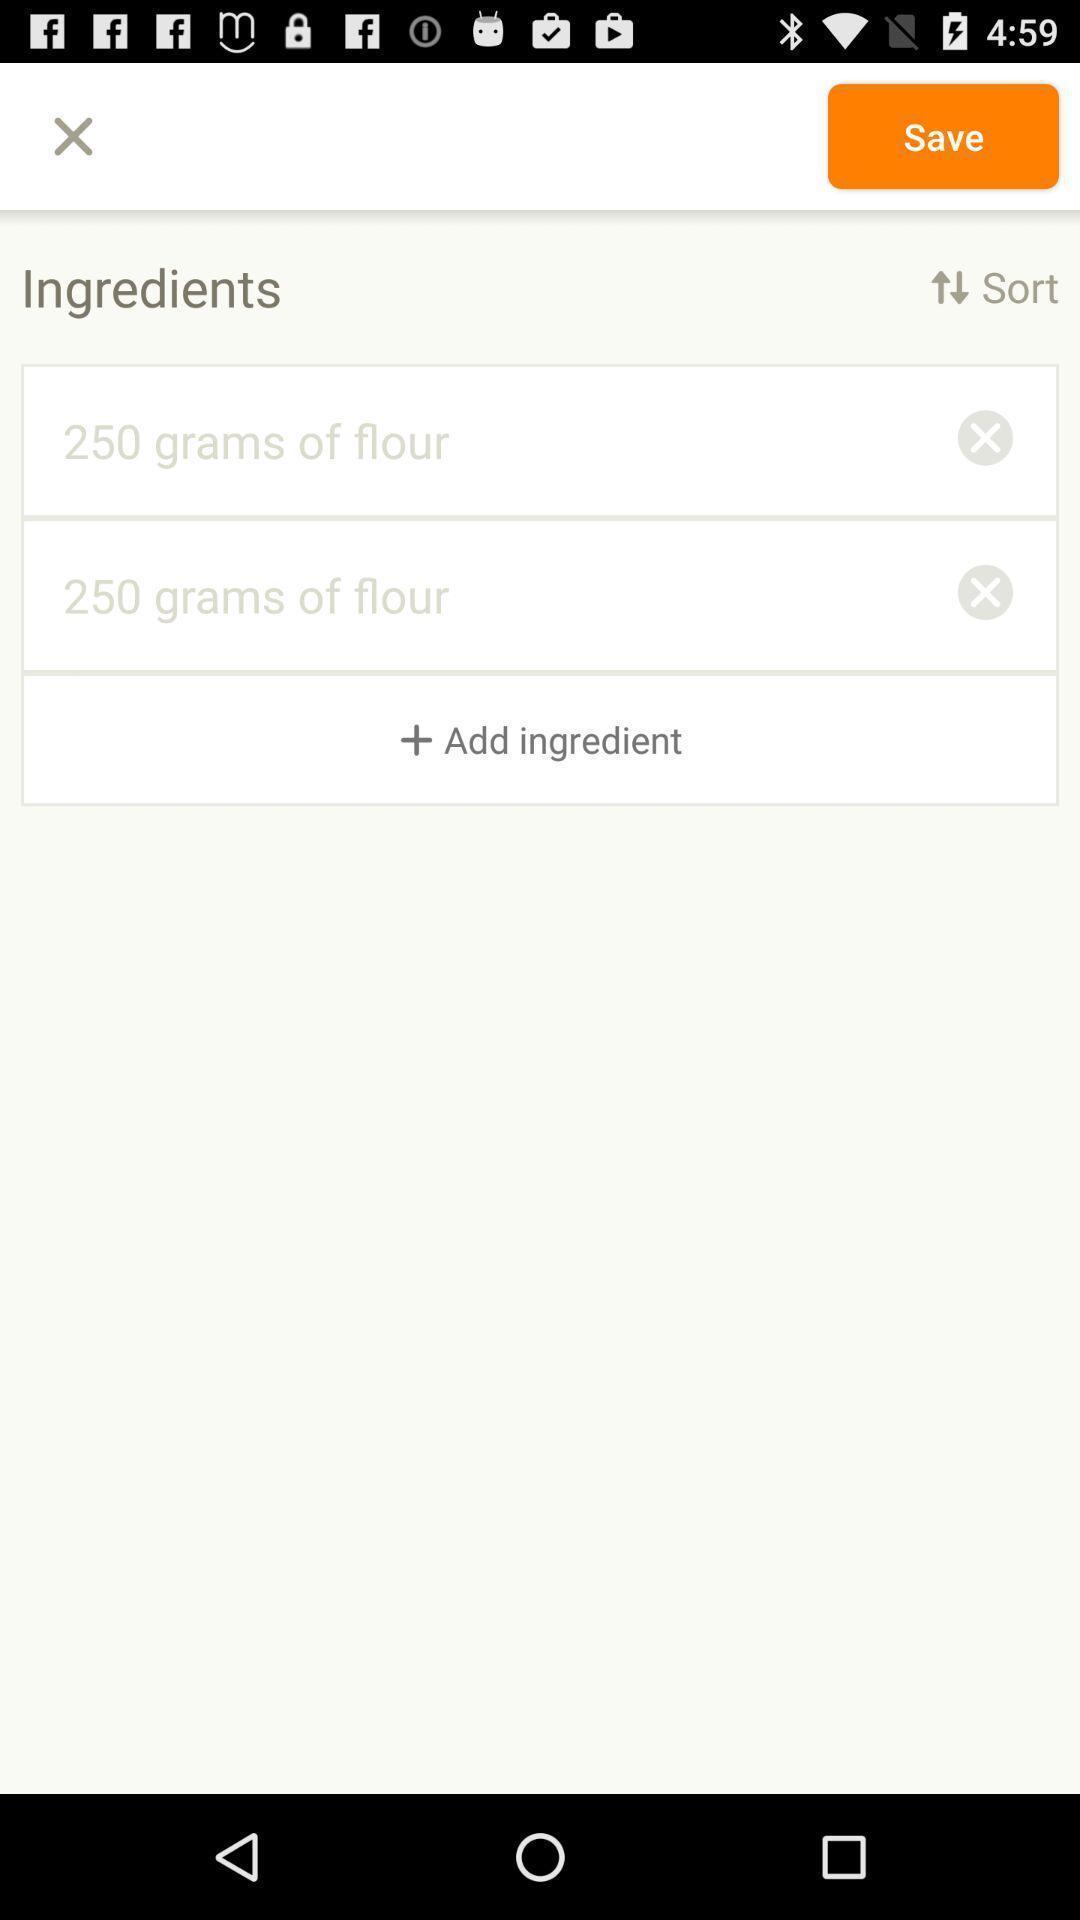What details can you identify in this image? Window displaying a cooking app. 